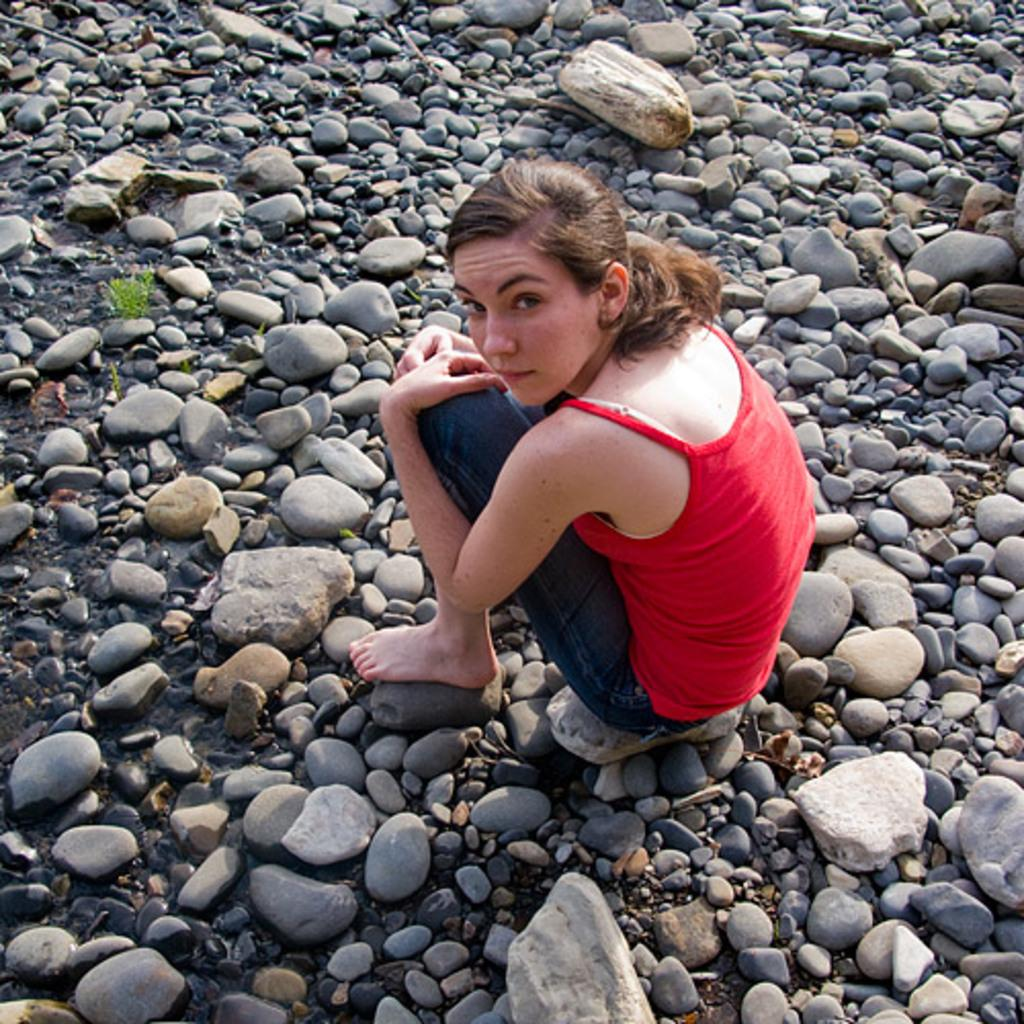What is covering the ground in the image? There are many stones on the ground in the image. What is the woman in the image doing? The woman is sitting on the ground in the image. What is the woman looking at in the image? The woman is looking at the picture in the image. Can you see a ball being thrown in the image? There is no ball or any indication of a ball being thrown in the image. What type of orange is the woman holding in the image? There is no orange present in the image; the woman is looking at a picture. 